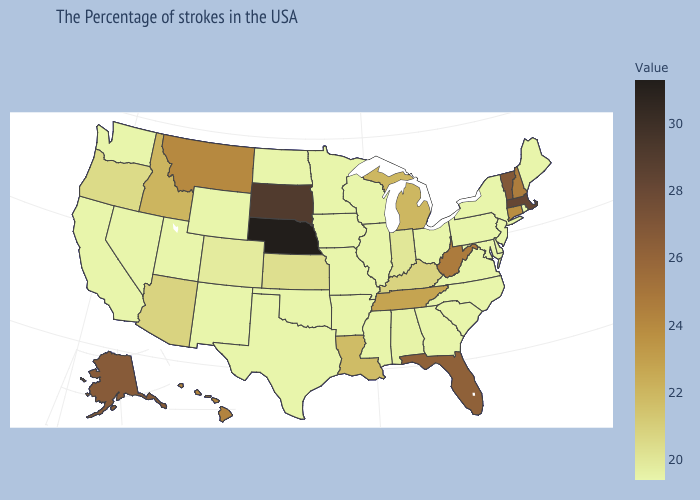Does Nebraska have a lower value than Maryland?
Write a very short answer. No. Does Nebraska have the highest value in the USA?
Write a very short answer. Yes. Which states hav the highest value in the Northeast?
Write a very short answer. Massachusetts. Does the map have missing data?
Give a very brief answer. No. Is the legend a continuous bar?
Give a very brief answer. Yes. Among the states that border Illinois , which have the lowest value?
Give a very brief answer. Wisconsin, Missouri, Iowa. 